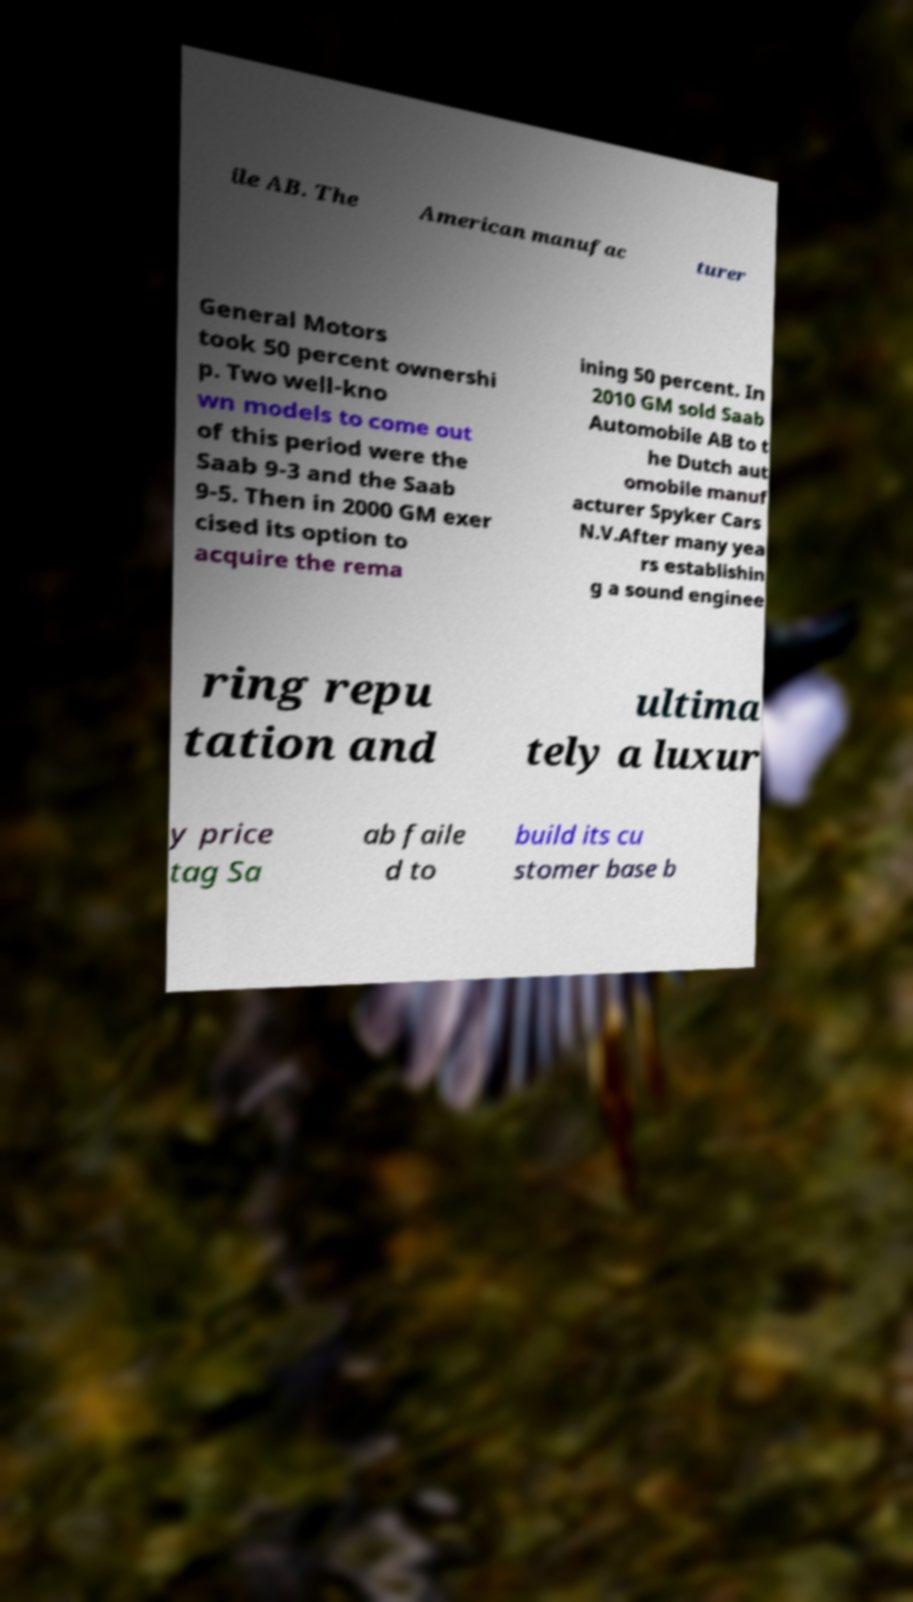Please read and relay the text visible in this image. What does it say? ile AB. The American manufac turer General Motors took 50 percent ownershi p. Two well-kno wn models to come out of this period were the Saab 9-3 and the Saab 9-5. Then in 2000 GM exer cised its option to acquire the rema ining 50 percent. In 2010 GM sold Saab Automobile AB to t he Dutch aut omobile manuf acturer Spyker Cars N.V.After many yea rs establishin g a sound enginee ring repu tation and ultima tely a luxur y price tag Sa ab faile d to build its cu stomer base b 